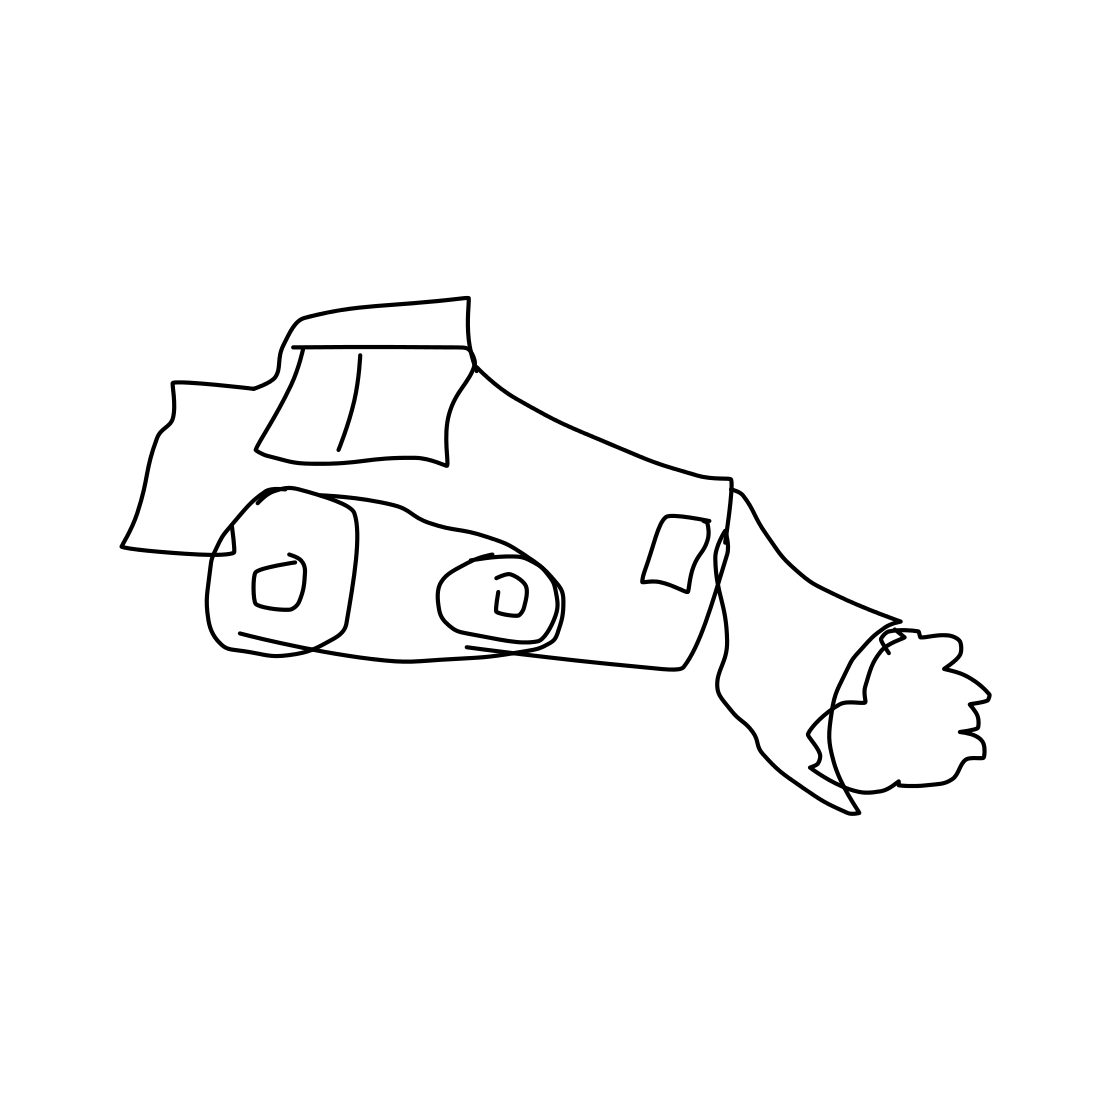Can you describe the drawing style of the vehicle? Certainly! The vehicle is depicted in a minimalistic line drawing style, emphasizing simplicity and abstract representation over detailed realism. 